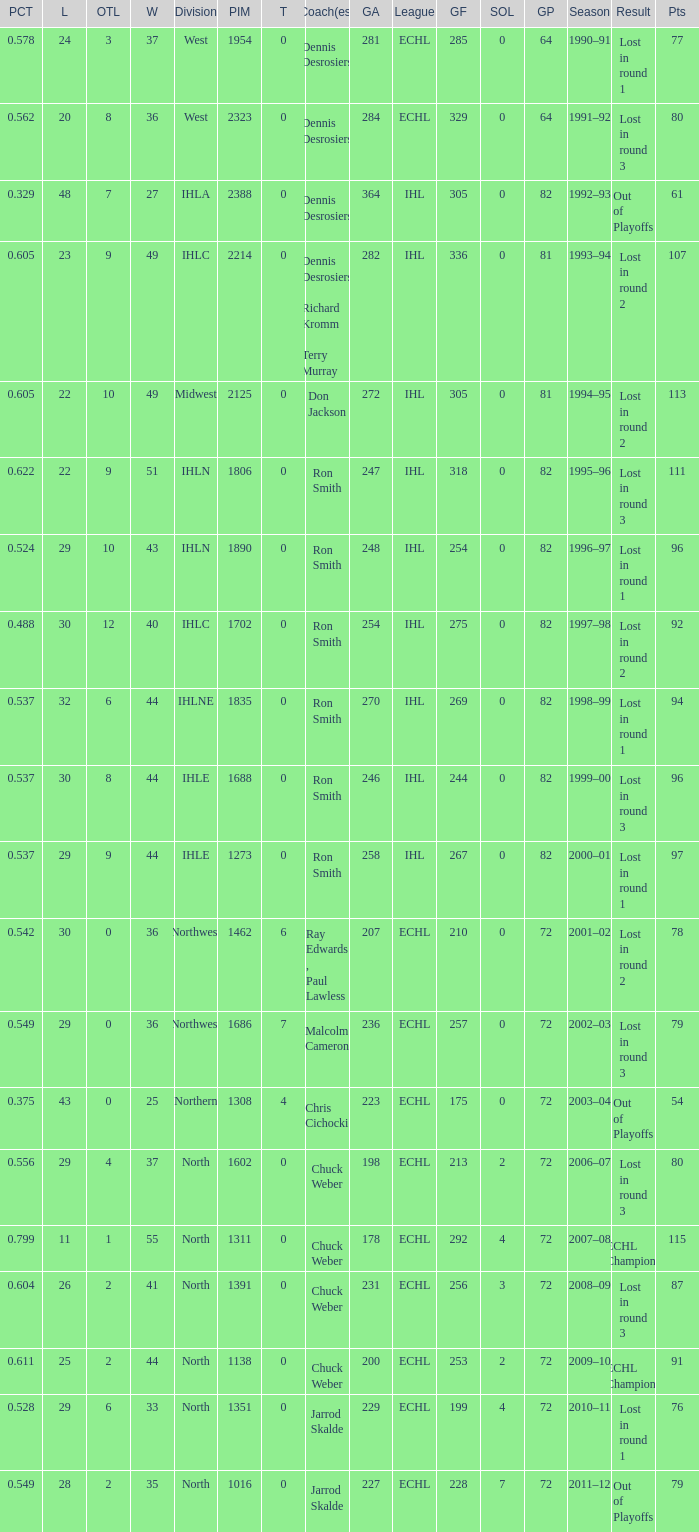How many season did the team lost in round 1 with a GP of 64? 1.0. 